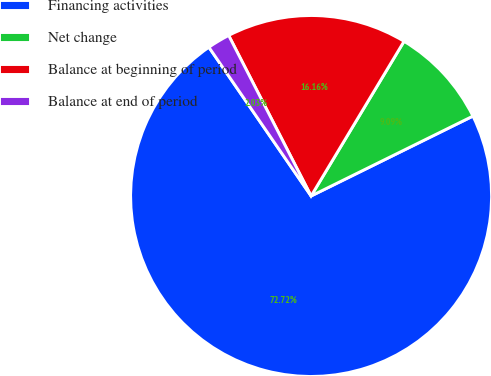Convert chart to OTSL. <chart><loc_0><loc_0><loc_500><loc_500><pie_chart><fcel>Financing activities<fcel>Net change<fcel>Balance at beginning of period<fcel>Balance at end of period<nl><fcel>72.72%<fcel>9.09%<fcel>16.16%<fcel>2.03%<nl></chart> 